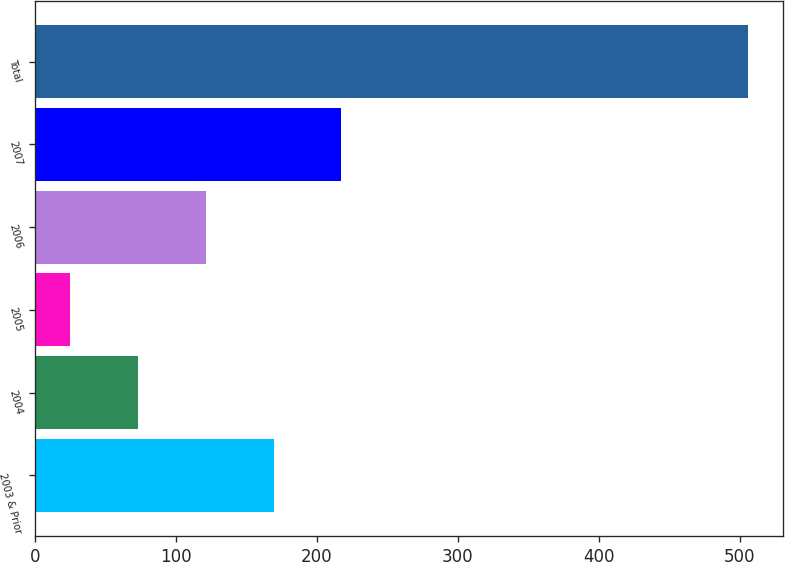Convert chart to OTSL. <chart><loc_0><loc_0><loc_500><loc_500><bar_chart><fcel>2003 & Prior<fcel>2004<fcel>2005<fcel>2006<fcel>2007<fcel>Total<nl><fcel>169.42<fcel>73.34<fcel>25.3<fcel>121.38<fcel>217.46<fcel>505.7<nl></chart> 